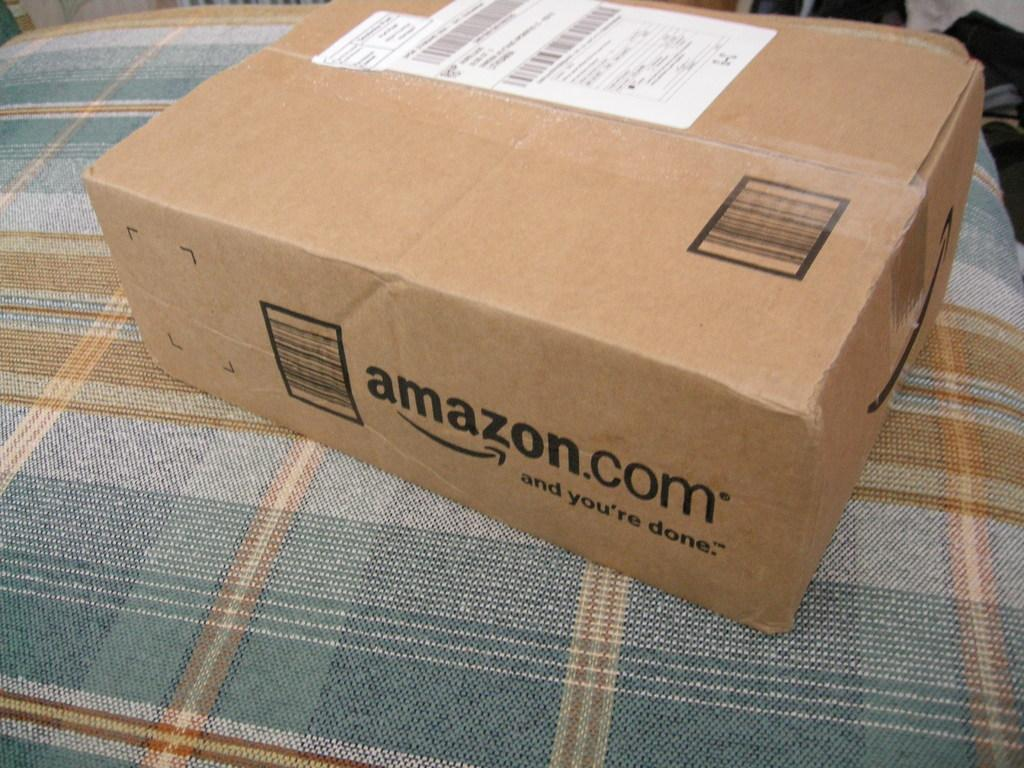<image>
Relay a brief, clear account of the picture shown. A brown box that says amazon.com on it. 